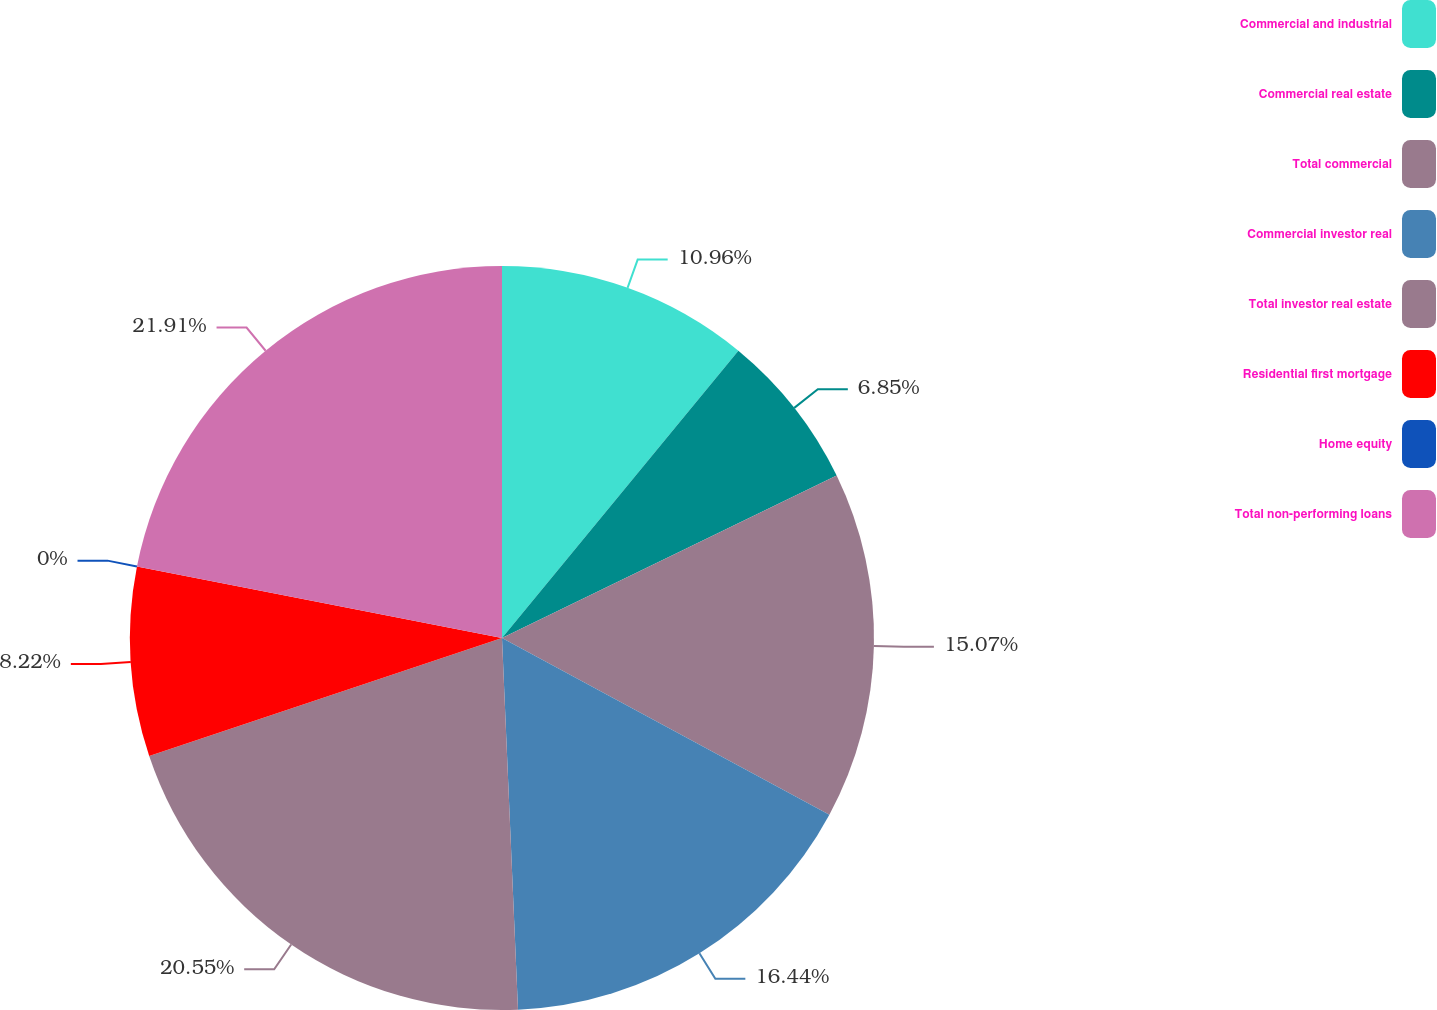Convert chart to OTSL. <chart><loc_0><loc_0><loc_500><loc_500><pie_chart><fcel>Commercial and industrial<fcel>Commercial real estate<fcel>Total commercial<fcel>Commercial investor real<fcel>Total investor real estate<fcel>Residential first mortgage<fcel>Home equity<fcel>Total non-performing loans<nl><fcel>10.96%<fcel>6.85%<fcel>15.07%<fcel>16.44%<fcel>20.55%<fcel>8.22%<fcel>0.0%<fcel>21.92%<nl></chart> 